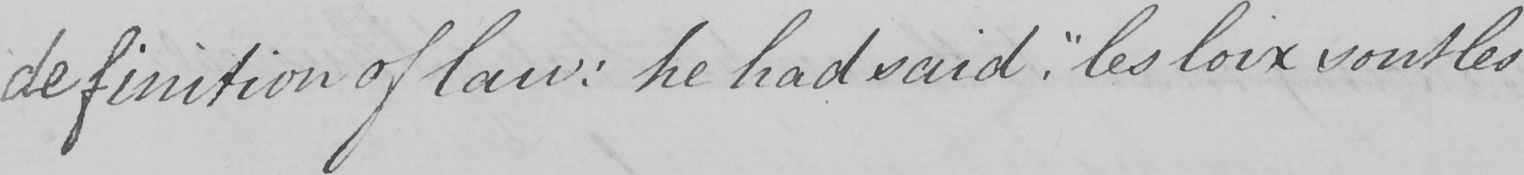What is written in this line of handwriting? definition of law :  he had said ,  " les loix sont les 